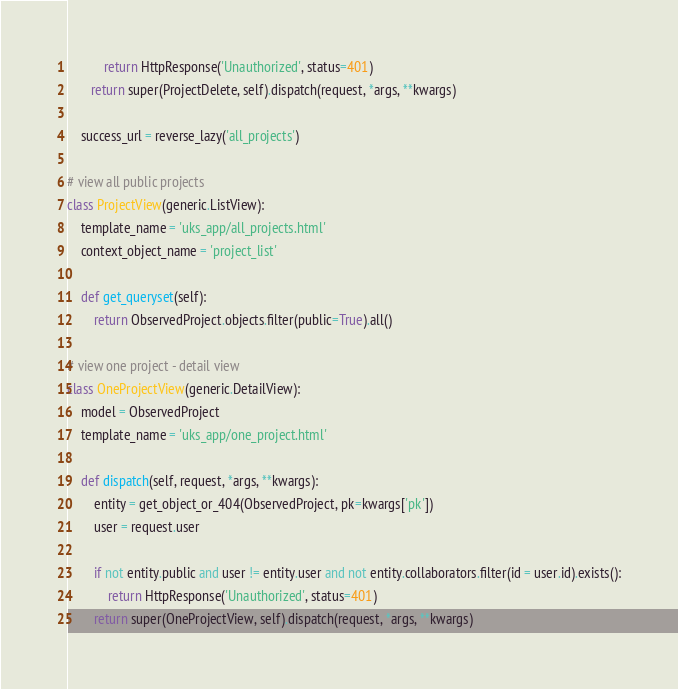<code> <loc_0><loc_0><loc_500><loc_500><_Python_>           return HttpResponse('Unauthorized', status=401)
       return super(ProjectDelete, self).dispatch(request, *args, **kwargs)

    success_url = reverse_lazy('all_projects')

# view all public projects
class ProjectView(generic.ListView):
    template_name = 'uks_app/all_projects.html'
    context_object_name = 'project_list'

    def get_queryset(self):
        return ObservedProject.objects.filter(public=True).all()

# view one project - detail view
class OneProjectView(generic.DetailView):
    model = ObservedProject
    template_name = 'uks_app/one_project.html'

    def dispatch(self, request, *args, **kwargs):
        entity = get_object_or_404(ObservedProject, pk=kwargs['pk'])
        user = request.user

        if not entity.public and user != entity.user and not entity.collaborators.filter(id = user.id).exists():
            return HttpResponse('Unauthorized', status=401)
        return super(OneProjectView, self).dispatch(request, *args, **kwargs)
</code> 